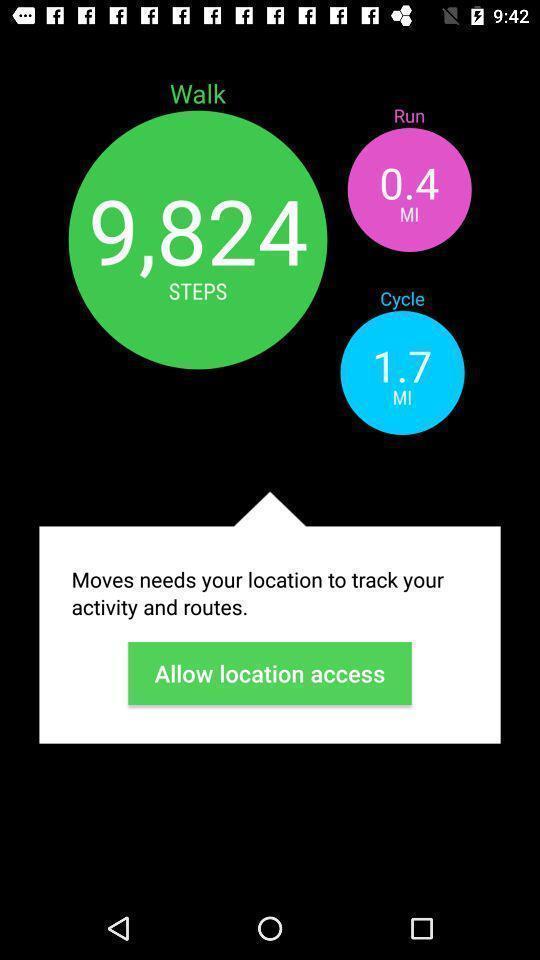Explain the elements present in this screenshot. Screen displaying demo instructions to access an application. 